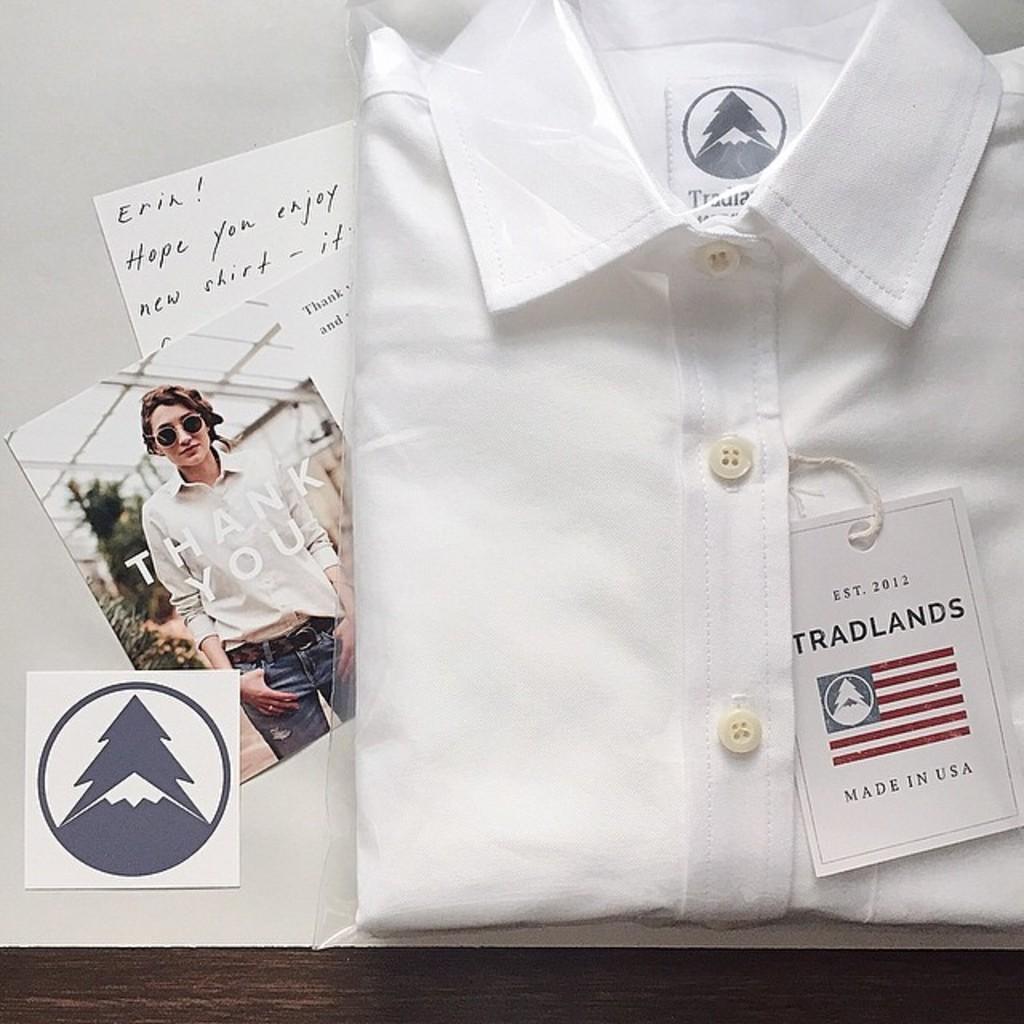Describe this image in one or two sentences. In this image I can see the white color shirt with tag. To the left I can see the paper and photos. These are on the white color surface. 